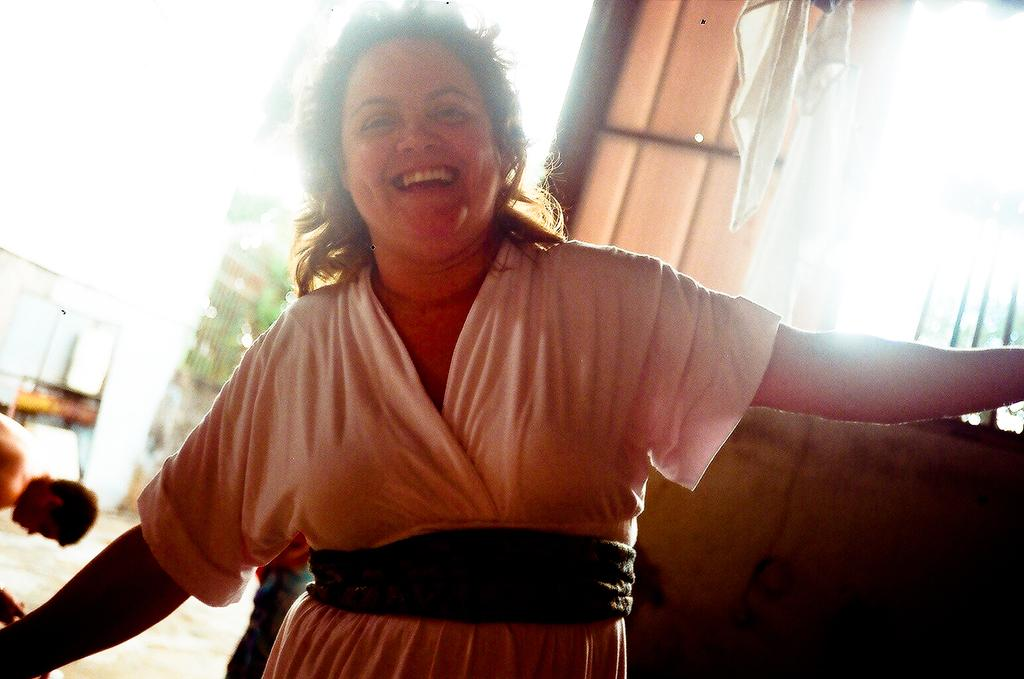Who is present in the image? There is a woman in the image. What is the woman doing in the image? The woman is smiling and stretching her arms. What can be seen on the right side of the image? There is a window on the right side of the image. Can you describe the background of the image? There is another person in the background of the image. What type of waste can be seen in the image? There is no waste present in the image. Where is the lunchroom located in the image? There is no mention of a lunchroom in the image. 